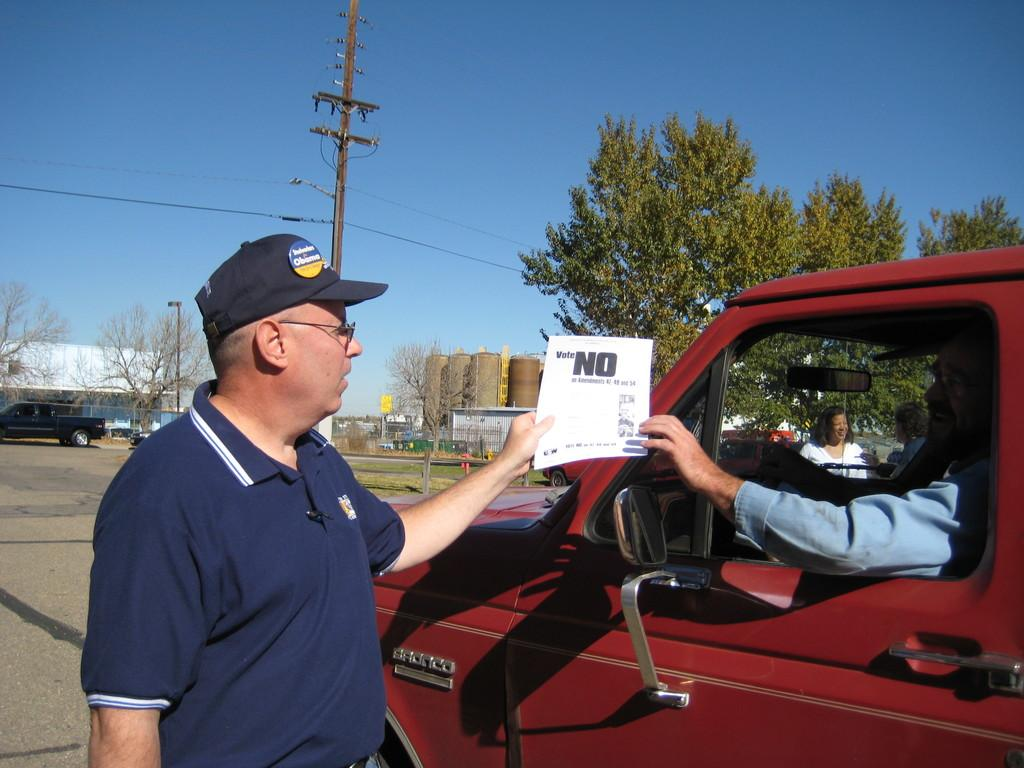What is the man in the image doing? The man is standing and holding a paper in his hand. Can you describe the other man in the image? There is a man sitting in a car. What can be seen in the background of the image? There is a woman, a tree, a truck, and a pole in the background of the image. What word is the cat saying in the image? There is no cat present in the image, so it is not possible to determine what word it might be saying. 